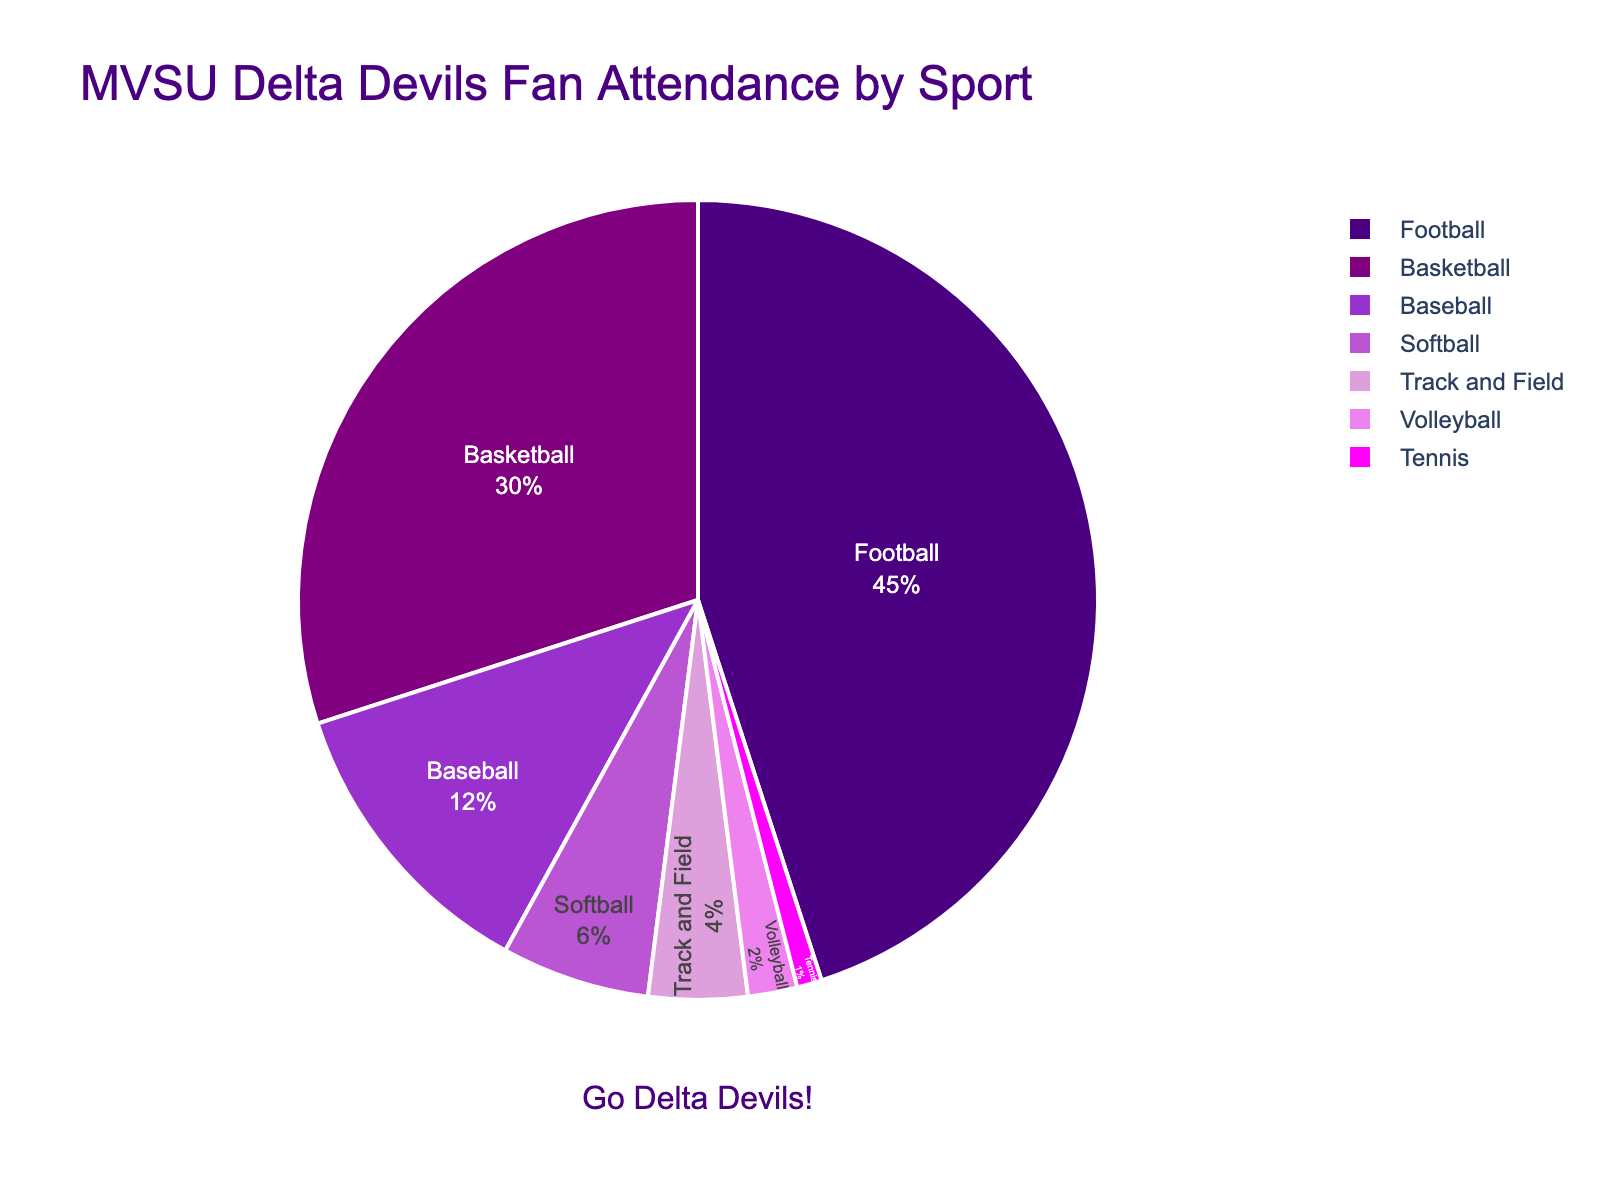What sport has the highest percentage of fan attendance? Looking at the pie chart, the sector representing Football is the largest. Thus, Football has the highest percentage of fan attendance.
Answer: Football Which sport has the lowest percentage of fan attendance? The smallest sector in the pie chart represents Tennis. Thus, Tennis has the lowest percentage of fan attendance.
Answer: Tennis What is the combined percentage of fan attendance for Basketball and Baseball? From the pie chart, Basketball has 30% and Baseball has 12%. Adding these together gives 30% + 12% = 42%.
Answer: 42% How much more fan attendance does Football have compared to Track and Field? Football has 45% and Track and Field has 4%. The difference is 45% - 4% = 41%.
Answer: 41% Which sports have a combined fan attendance percentage less than 10%? From the pie chart, Softball has 6%, Volleyball has 2%, and Tennis has 1%, so Softball + Volleyball + Tennis = 6% + 2% + 1% = 9%, which is less than 10%.
Answer: Softball, Volleyball, Tennis What is the total percentage of fan attendance for sports with less than 10% each? The relevant sports are Baseball (12%), Softball (6%), Track and Field (4%), Volleyball (2%), and Tennis (1%). Adding these together: 12% + 6% + 4% + 2% + 1% = 25%.
Answer: 25% How does the fan attendance for Volleyball compare to that for Softball? Volleyball has a 2% fan attendance, while Softball has 6%. Volleyball has less attendance than Softball.
Answer: Volleyball < Softball What visual clues indicate which sport is most popular among fans? The Football sector is the largest slice of the pie, which visually indicates that it has the highest fan attendance.
Answer: Largest slice of the pie If the fan attendance for all sports except Football increased by 5%, what would be the new attendance percentage for Basketball? Current Basketball attendance is 30%. If it increases by 5%, the new percentage will be 30% + 5% = 35%.
Answer: 35% 